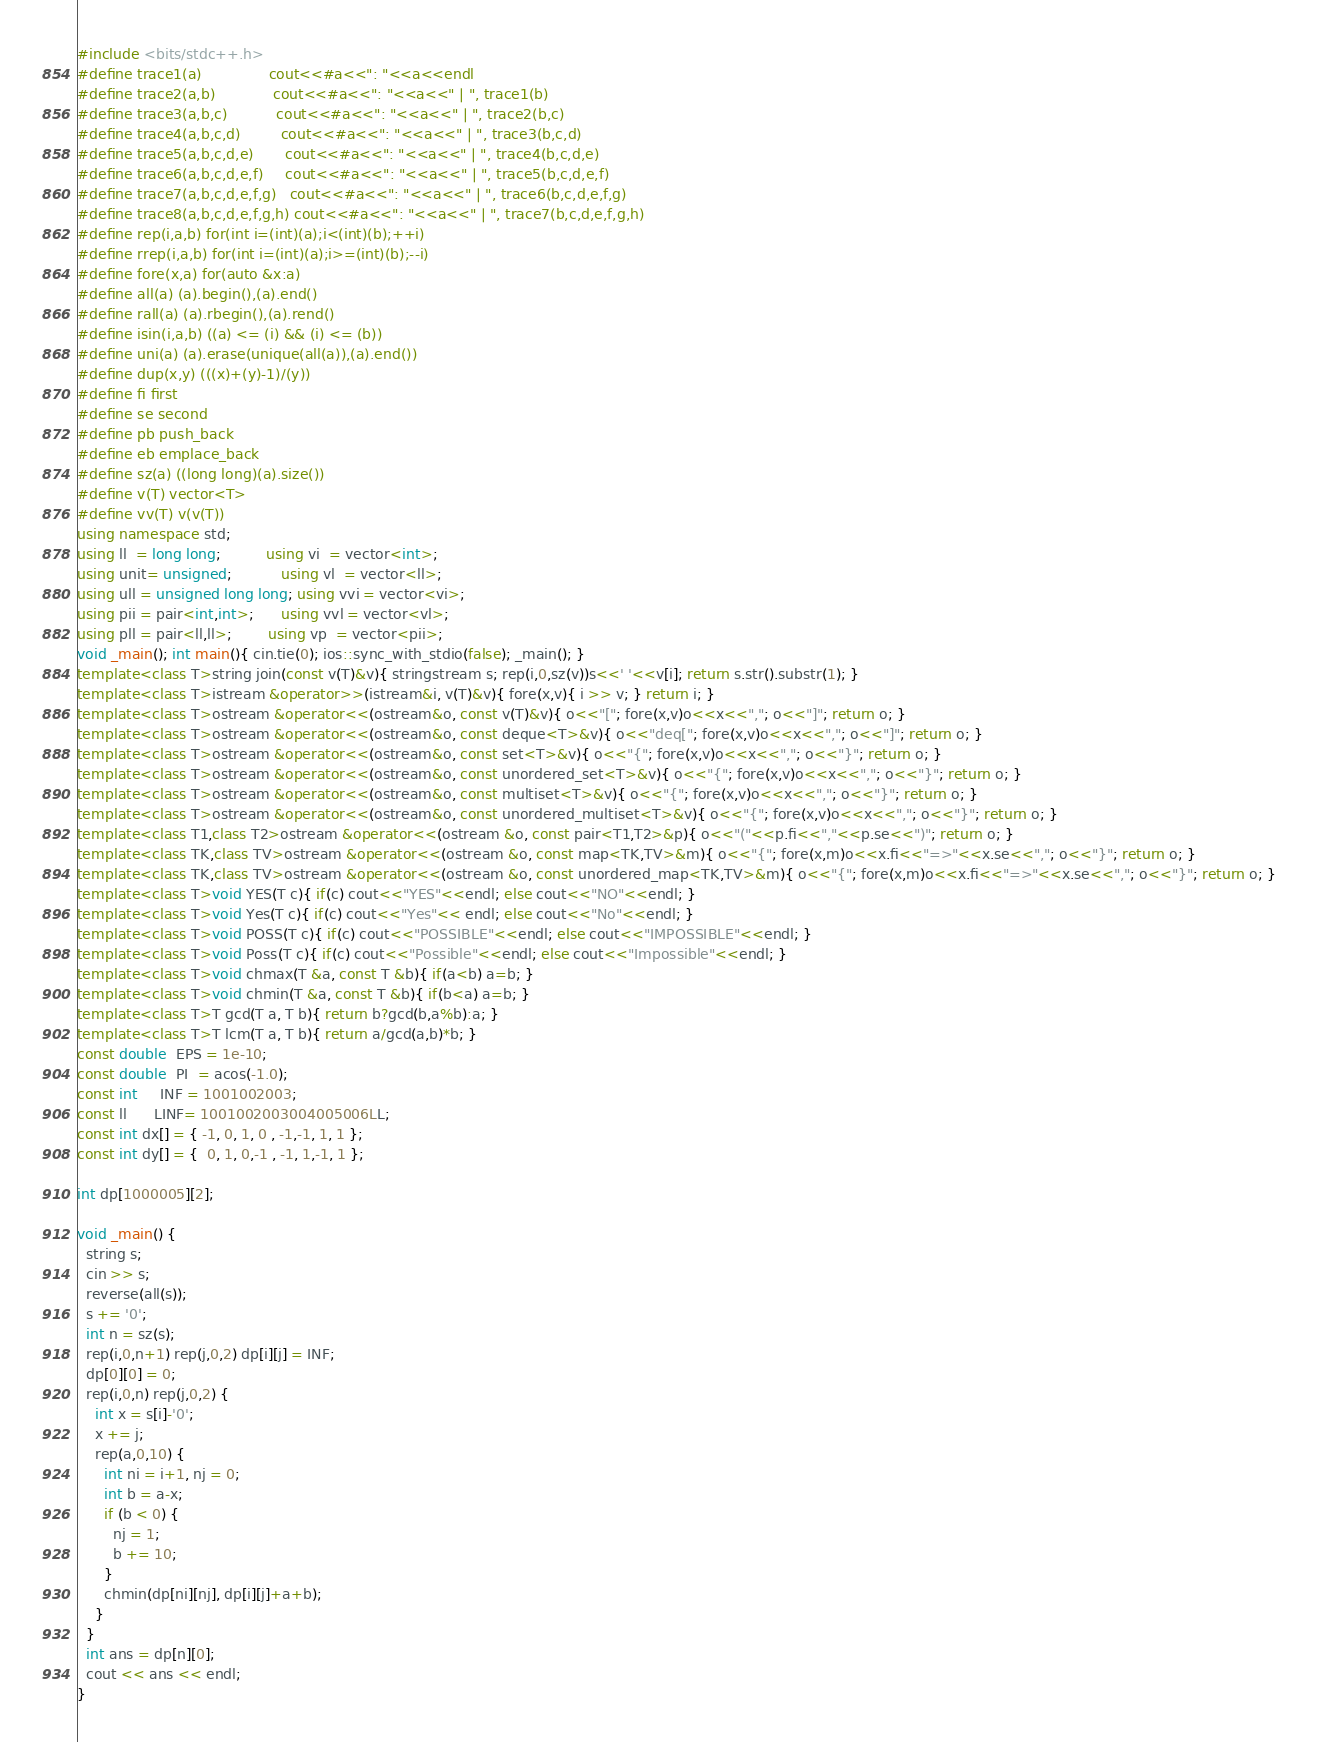Convert code to text. <code><loc_0><loc_0><loc_500><loc_500><_C++_>#include <bits/stdc++.h>
#define trace1(a)               cout<<#a<<": "<<a<<endl
#define trace2(a,b)             cout<<#a<<": "<<a<<" | ", trace1(b)
#define trace3(a,b,c)           cout<<#a<<": "<<a<<" | ", trace2(b,c)
#define trace4(a,b,c,d)         cout<<#a<<": "<<a<<" | ", trace3(b,c,d)
#define trace5(a,b,c,d,e)       cout<<#a<<": "<<a<<" | ", trace4(b,c,d,e)
#define trace6(a,b,c,d,e,f)     cout<<#a<<": "<<a<<" | ", trace5(b,c,d,e,f)
#define trace7(a,b,c,d,e,f,g)   cout<<#a<<": "<<a<<" | ", trace6(b,c,d,e,f,g)
#define trace8(a,b,c,d,e,f,g,h) cout<<#a<<": "<<a<<" | ", trace7(b,c,d,e,f,g,h)
#define rep(i,a,b) for(int i=(int)(a);i<(int)(b);++i)
#define rrep(i,a,b) for(int i=(int)(a);i>=(int)(b);--i)
#define fore(x,a) for(auto &x:a)
#define all(a) (a).begin(),(a).end()
#define rall(a) (a).rbegin(),(a).rend()
#define isin(i,a,b) ((a) <= (i) && (i) <= (b))
#define uni(a) (a).erase(unique(all(a)),(a).end())
#define dup(x,y) (((x)+(y)-1)/(y))
#define fi first
#define se second
#define pb push_back
#define eb emplace_back
#define sz(a) ((long long)(a).size())
#define v(T) vector<T>
#define vv(T) v(v(T))
using namespace std;
using ll  = long long;          using vi  = vector<int>;
using unit= unsigned;           using vl  = vector<ll>;
using ull = unsigned long long; using vvi = vector<vi>;
using pii = pair<int,int>;      using vvl = vector<vl>;
using pll = pair<ll,ll>;        using vp  = vector<pii>;
void _main(); int main(){ cin.tie(0); ios::sync_with_stdio(false); _main(); }
template<class T>string join(const v(T)&v){ stringstream s; rep(i,0,sz(v))s<<' '<<v[i]; return s.str().substr(1); }
template<class T>istream &operator>>(istream&i, v(T)&v){ fore(x,v){ i >> v; } return i; }
template<class T>ostream &operator<<(ostream&o, const v(T)&v){ o<<"["; fore(x,v)o<<x<<","; o<<"]"; return o; }
template<class T>ostream &operator<<(ostream&o, const deque<T>&v){ o<<"deq["; fore(x,v)o<<x<<","; o<<"]"; return o; }
template<class T>ostream &operator<<(ostream&o, const set<T>&v){ o<<"{"; fore(x,v)o<<x<<","; o<<"}"; return o; }
template<class T>ostream &operator<<(ostream&o, const unordered_set<T>&v){ o<<"{"; fore(x,v)o<<x<<","; o<<"}"; return o; }
template<class T>ostream &operator<<(ostream&o, const multiset<T>&v){ o<<"{"; fore(x,v)o<<x<<","; o<<"}"; return o; }
template<class T>ostream &operator<<(ostream&o, const unordered_multiset<T>&v){ o<<"{"; fore(x,v)o<<x<<","; o<<"}"; return o; }
template<class T1,class T2>ostream &operator<<(ostream &o, const pair<T1,T2>&p){ o<<"("<<p.fi<<","<<p.se<<")"; return o; }
template<class TK,class TV>ostream &operator<<(ostream &o, const map<TK,TV>&m){ o<<"{"; fore(x,m)o<<x.fi<<"=>"<<x.se<<","; o<<"}"; return o; }
template<class TK,class TV>ostream &operator<<(ostream &o, const unordered_map<TK,TV>&m){ o<<"{"; fore(x,m)o<<x.fi<<"=>"<<x.se<<","; o<<"}"; return o; }
template<class T>void YES(T c){ if(c) cout<<"YES"<<endl; else cout<<"NO"<<endl; }
template<class T>void Yes(T c){ if(c) cout<<"Yes"<< endl; else cout<<"No"<<endl; }
template<class T>void POSS(T c){ if(c) cout<<"POSSIBLE"<<endl; else cout<<"IMPOSSIBLE"<<endl; }
template<class T>void Poss(T c){ if(c) cout<<"Possible"<<endl; else cout<<"Impossible"<<endl; }
template<class T>void chmax(T &a, const T &b){ if(a<b) a=b; }
template<class T>void chmin(T &a, const T &b){ if(b<a) a=b; }
template<class T>T gcd(T a, T b){ return b?gcd(b,a%b):a; }
template<class T>T lcm(T a, T b){ return a/gcd(a,b)*b; }
const double  EPS = 1e-10;
const double  PI  = acos(-1.0);
const int     INF = 1001002003;
const ll      LINF= 1001002003004005006LL;
const int dx[] = { -1, 0, 1, 0 , -1,-1, 1, 1 };
const int dy[] = {  0, 1, 0,-1 , -1, 1,-1, 1 };

int dp[1000005][2];

void _main() {
  string s;
  cin >> s;
  reverse(all(s));
  s += '0';
  int n = sz(s);
  rep(i,0,n+1) rep(j,0,2) dp[i][j] = INF;
  dp[0][0] = 0;
  rep(i,0,n) rep(j,0,2) {
    int x = s[i]-'0';
    x += j;
    rep(a,0,10) {
      int ni = i+1, nj = 0;
      int b = a-x;
      if (b < 0) {
        nj = 1;
        b += 10;
      }
      chmin(dp[ni][nj], dp[i][j]+a+b);
    }
  }
  int ans = dp[n][0];
  cout << ans << endl;
}</code> 